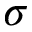Convert formula to latex. <formula><loc_0><loc_0><loc_500><loc_500>\sigma</formula> 